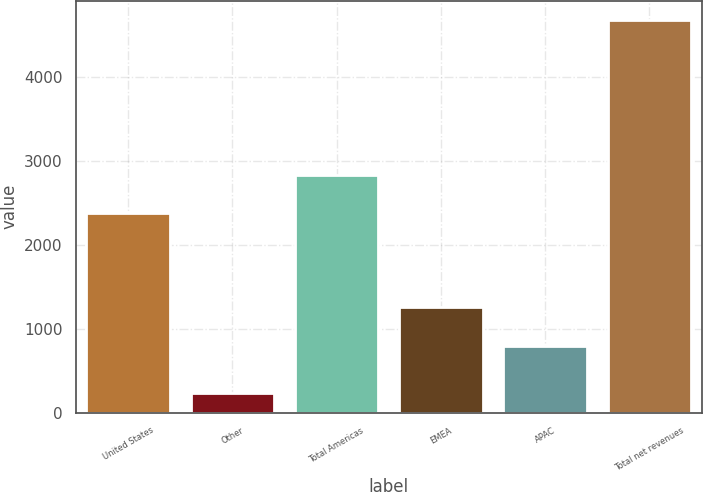Convert chart. <chart><loc_0><loc_0><loc_500><loc_500><bar_chart><fcel>United States<fcel>Other<fcel>Total Americas<fcel>EMEA<fcel>APAC<fcel>Total net revenues<nl><fcel>2381.5<fcel>232<fcel>2825.21<fcel>1256.9<fcel>798.7<fcel>4669.1<nl></chart> 